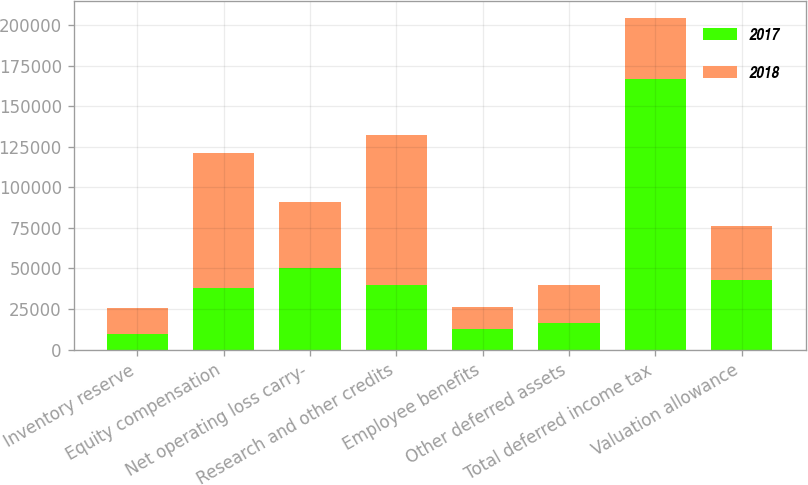Convert chart to OTSL. <chart><loc_0><loc_0><loc_500><loc_500><stacked_bar_chart><ecel><fcel>Inventory reserve<fcel>Equity compensation<fcel>Net operating loss carry-<fcel>Research and other credits<fcel>Employee benefits<fcel>Other deferred assets<fcel>Total deferred income tax<fcel>Valuation allowance<nl><fcel>2017<fcel>9894<fcel>37724<fcel>50128<fcel>39513<fcel>12842<fcel>16620<fcel>166721<fcel>42787<nl><fcel>2018<fcel>15599<fcel>83333<fcel>40575<fcel>92793<fcel>13247<fcel>23355<fcel>37724<fcel>33104<nl></chart> 